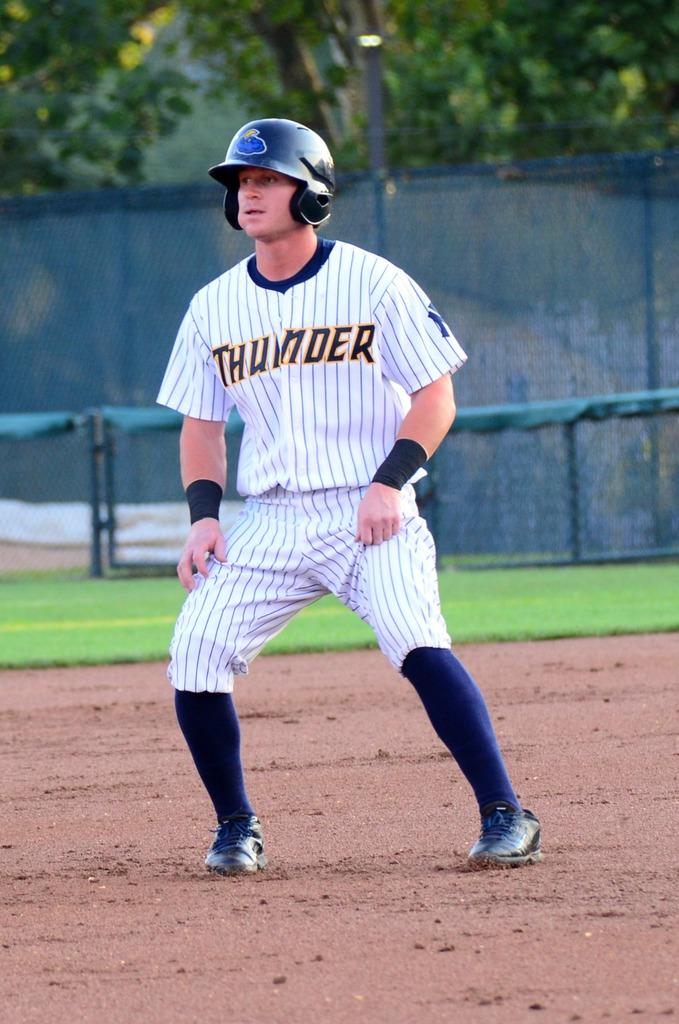<image>
Render a clear and concise summary of the photo. A baseball player has a jersey with the team name Thunder on it. 